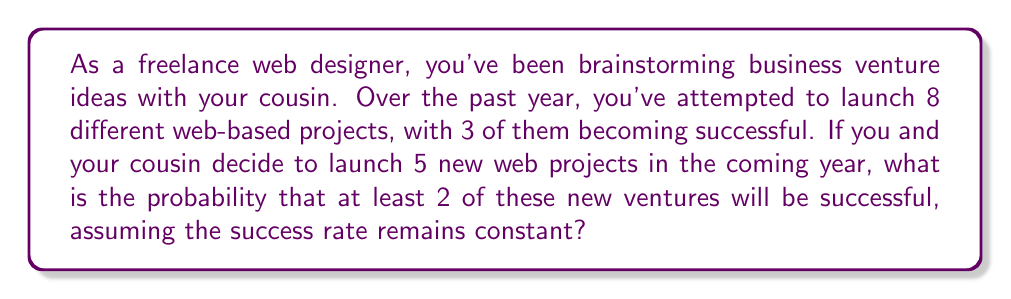Show me your answer to this math problem. Let's approach this step-by-step:

1) First, we need to calculate the probability of success for a single venture:
   $p = \frac{\text{number of successful ventures}}{\text{total number of ventures}} = \frac{3}{8} = 0.375$

2) The probability of failure for a single venture is:
   $q = 1 - p = 1 - 0.375 = 0.625$

3) We want to find the probability of at least 2 successes out of 5 ventures. It's easier to calculate the probability of 0 or 1 success and subtract from 1:

   $P(\text{at least 2 successes}) = 1 - P(0 \text{ successes}) - P(1 \text{ success})$

4) We can use the binomial probability formula:
   $P(X = k) = \binom{n}{k} p^k q^{n-k}$

   Where $n$ is the number of trials (5 in this case), $k$ is the number of successes, $p$ is the probability of success, and $q$ is the probability of failure.

5) Calculating $P(0 \text{ successes})$:
   $P(0) = \binom{5}{0} (0.375)^0 (0.625)^5 = 1 \cdot 1 \cdot 0.0954 = 0.0954$

6) Calculating $P(1 \text{ success})$:
   $P(1) = \binom{5}{1} (0.375)^1 (0.625)^4 = 5 \cdot 0.375 \cdot 0.1526 = 0.2861$

7) Therefore, the probability of at least 2 successes is:
   $1 - P(0) - P(1) = 1 - 0.0954 - 0.2861 = 0.6185$
Answer: The probability that at least 2 of the 5 new web projects will be successful is approximately 0.6185 or 61.85%. 